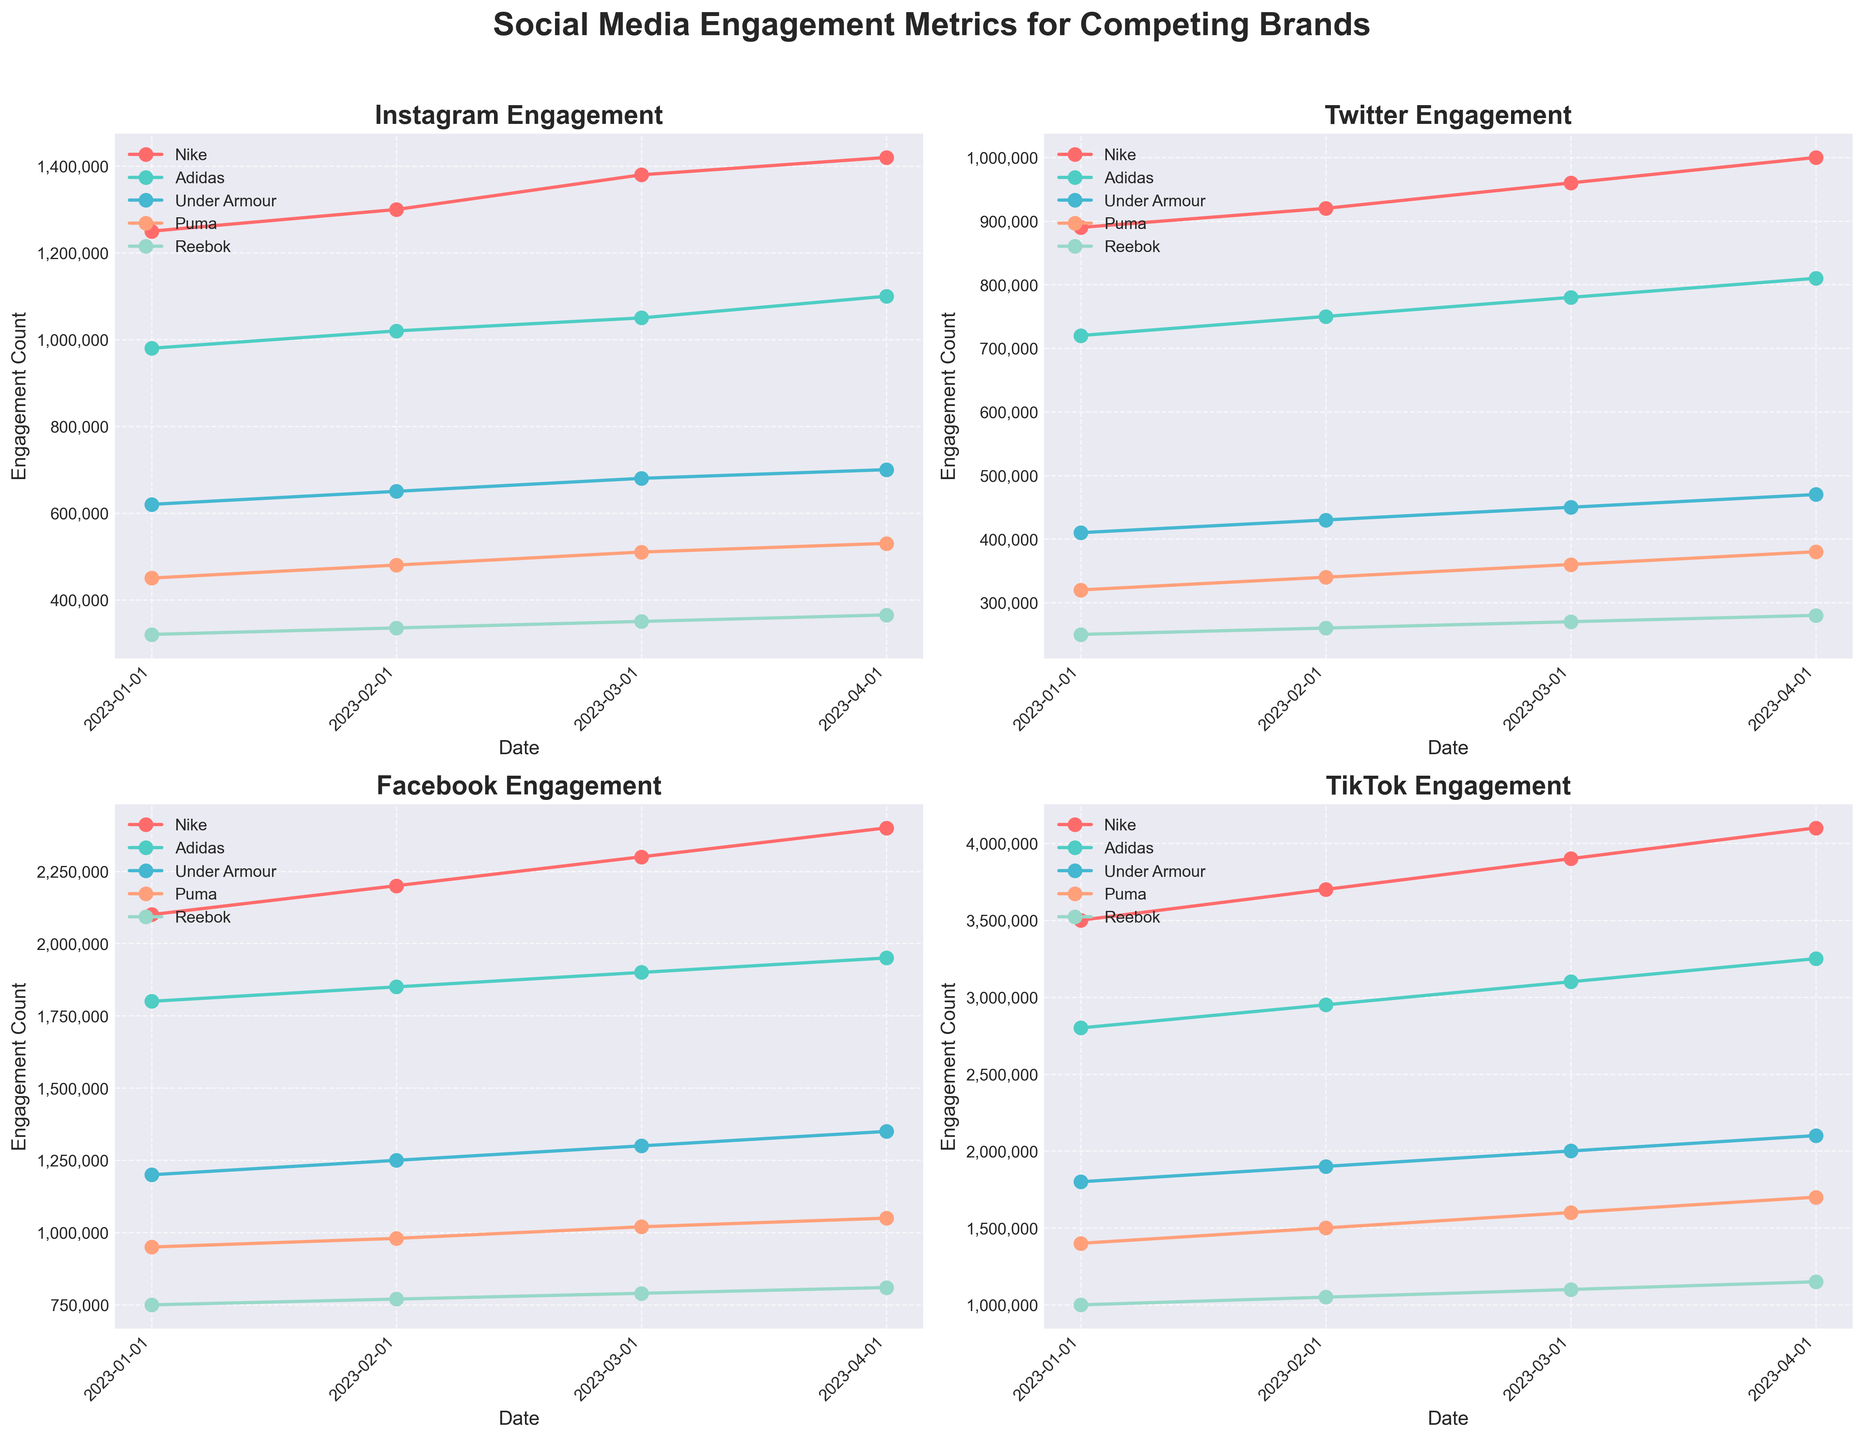What's the difference in engagement between Nike and Adidas on TikTok in April 2023? Look at the TikTok engagement for Nike and Adidas in April 2023. Nike has 4,100,000 engagements, and Adidas has 3,250,000 engagements. Subtract the engagements of Adidas from Nike. 4,100,000 - 3,250,000 = 850,000
Answer: 850,000 Which brand has consistently increased its engagement on Facebook from January to April 2023? Observe the engagement trends for each brand on Facebook from January to April 2023. Nike, Adidas, Under Armour, Puma, and Reebok all show increasing trends, but the key phrase here is "consistently." All brands fit this description.
Answer: Nike, Adidas, Under Armour, Puma, Reebok In March 2023, which platform did Under Armour have the highest engagement on? Compare Under Armour’s engagement metrics across all platforms in March 2023. The engagements are: Instagram (680,000), Twitter (450,000), Facebook (1,300,000), and TikTok (2,000,000). TikTok has the highest engagement.
Answer: TikTok What is Puma’s total engagement across all platforms in April 2023? Sum up Puma’s engagement across Instagram (530,000), Twitter (380,000), Facebook (1,050,000), and TikTok (1,700,000) in April 2023. 530,000 + 380,000 + 1,050,000 + 1,700,000 = 3,660,000
Answer: 3,660,000 What is the average engagement of Reebok on Instagram from January to April 2023? Sum Reebok’s Instagram engagements over the four months: 320,000 + 335,000 + 350,000 + 365,000 = 1,370,000. Divide by the number of months (4): 1,370,000 / 4 = 342,500
Answer: 342,500 Among the brands, who showed the largest engagement increase on Twitter from January to April 2023? Calculate the difference in engagement from January to April 2023 for each brand on Twitter. Nike: 1,000,000 - 890,000 = 110,000; Adidas: 810,000 - 720,000 = 90,000; Under Armour: 470,000 - 410,000 = 60,000; Puma: 380,000 - 320,000 = 60,000; Reebok: 280,000 - 250,000 = 30,000. Nike has the largest increase.
Answer: Nike Which platform does Adidas have the highest engagement in April 2023? Compare Adidas' engagement across all platforms in April 2023: Instagram (1,100,000), Twitter (810,000), Facebook (1,950,000), TikTok (3,250,000). TikTok has the highest engagement.
Answer: TikTok 